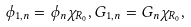<formula> <loc_0><loc_0><loc_500><loc_500>\phi _ { 1 , n } = \phi _ { n } \chi _ { R _ { 0 } } , G _ { 1 , n } = G _ { n } \chi _ { R _ { 0 } } ,</formula> 